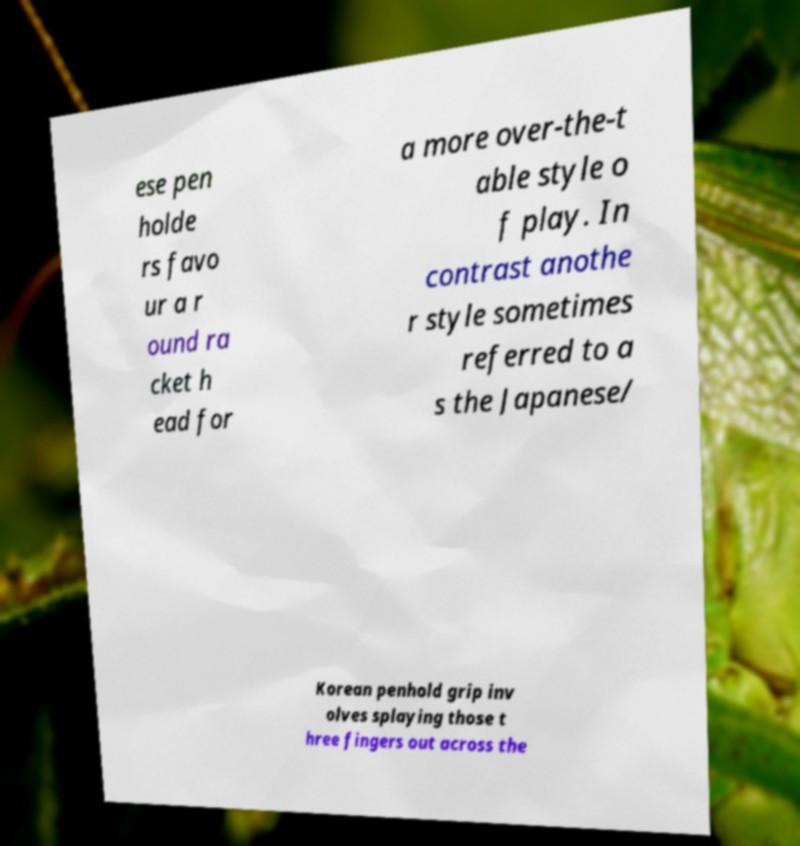Can you read and provide the text displayed in the image?This photo seems to have some interesting text. Can you extract and type it out for me? ese pen holde rs favo ur a r ound ra cket h ead for a more over-the-t able style o f play. In contrast anothe r style sometimes referred to a s the Japanese/ Korean penhold grip inv olves splaying those t hree fingers out across the 